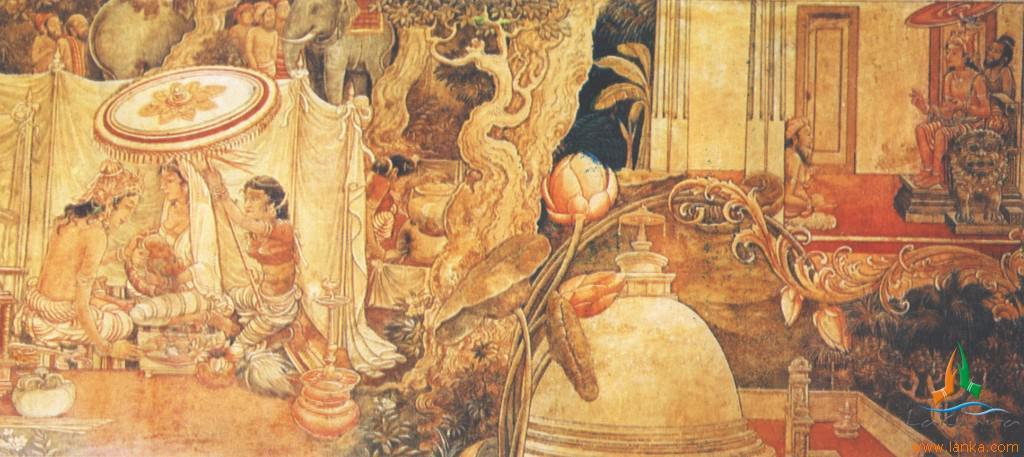What is the main subject of the picture? The main subject of the picture is art. What are the people in the picture doing? There are people sitting and standing in the picture. What type of art is depicted in the picture? There is art depicting animals in the picture. What type of seating is available in the picture? There are sitting chairs in the picture. How many lizards are present in the art depicting animals in the image? There is no mention of lizards in the art depicting animals in the image. What type of silk is used to create the sitting chairs in the image? There is no information about the material used to create the sitting chairs in the image. 